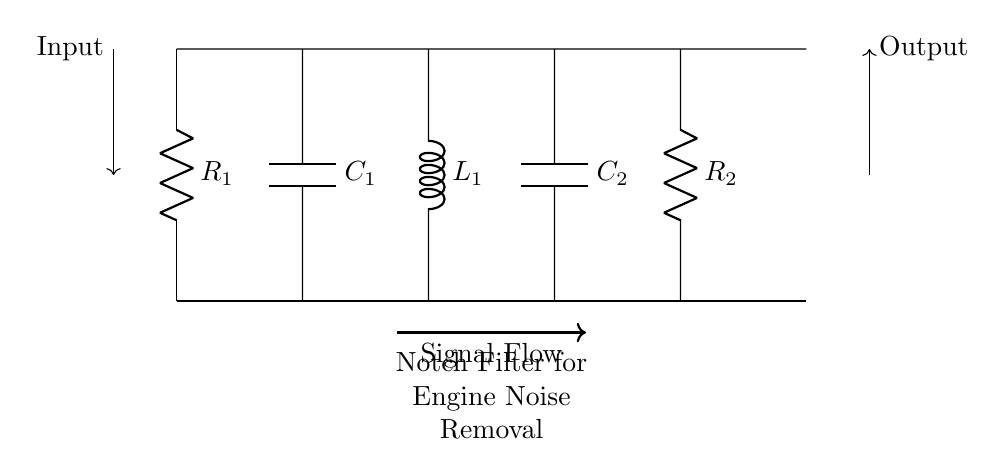What is the type of filter illustrated in this circuit? The circuit is classified as a notch filter, which is specifically designed to eliminate unwanted frequencies while allowing others to pass through. This can be determined by the arrangement of components and the overall purpose indicated in the diagram header.
Answer: Notch filter How many resistors are present in the circuit? There are two resistors in the circuit, shown as R1 and R2. Counting the components depicted in the circuit leads to this conclusion.
Answer: 2 What role does the capacitor C1 play in this circuit? Capacitor C1 is part of the notch filter configuration and helps in setting the specific frequency that the filter will affect. Capacitors in such configurations typically store and release energy, affecting the signal as it passes through.
Answer: Frequency-setting What is the output direction indicated in the diagram? The output direction is illustrated by an arrow pointing to the right, indicating the flow of processed signal from the filter towards the output device or system.
Answer: Right Which component is primarily involved in signal attenuation at the notch frequency? The inductor L1 is primarily responsible for providing attenuation at the notch frequency, due to its properties of opposing changes in current, which is essential for filtering out specific frequencies.
Answer: Inductor Why are there two capacitors in this notch filter circuit? The two capacitors, C1 and C2, are used together to create a specific resonance and improve the filter's ability to reject the unwanted noise at the notch frequency. This arrangement enhances the circuit's performance by capturing a wider range of frequencies to diminish noise interference.
Answer: Resonance and performance 